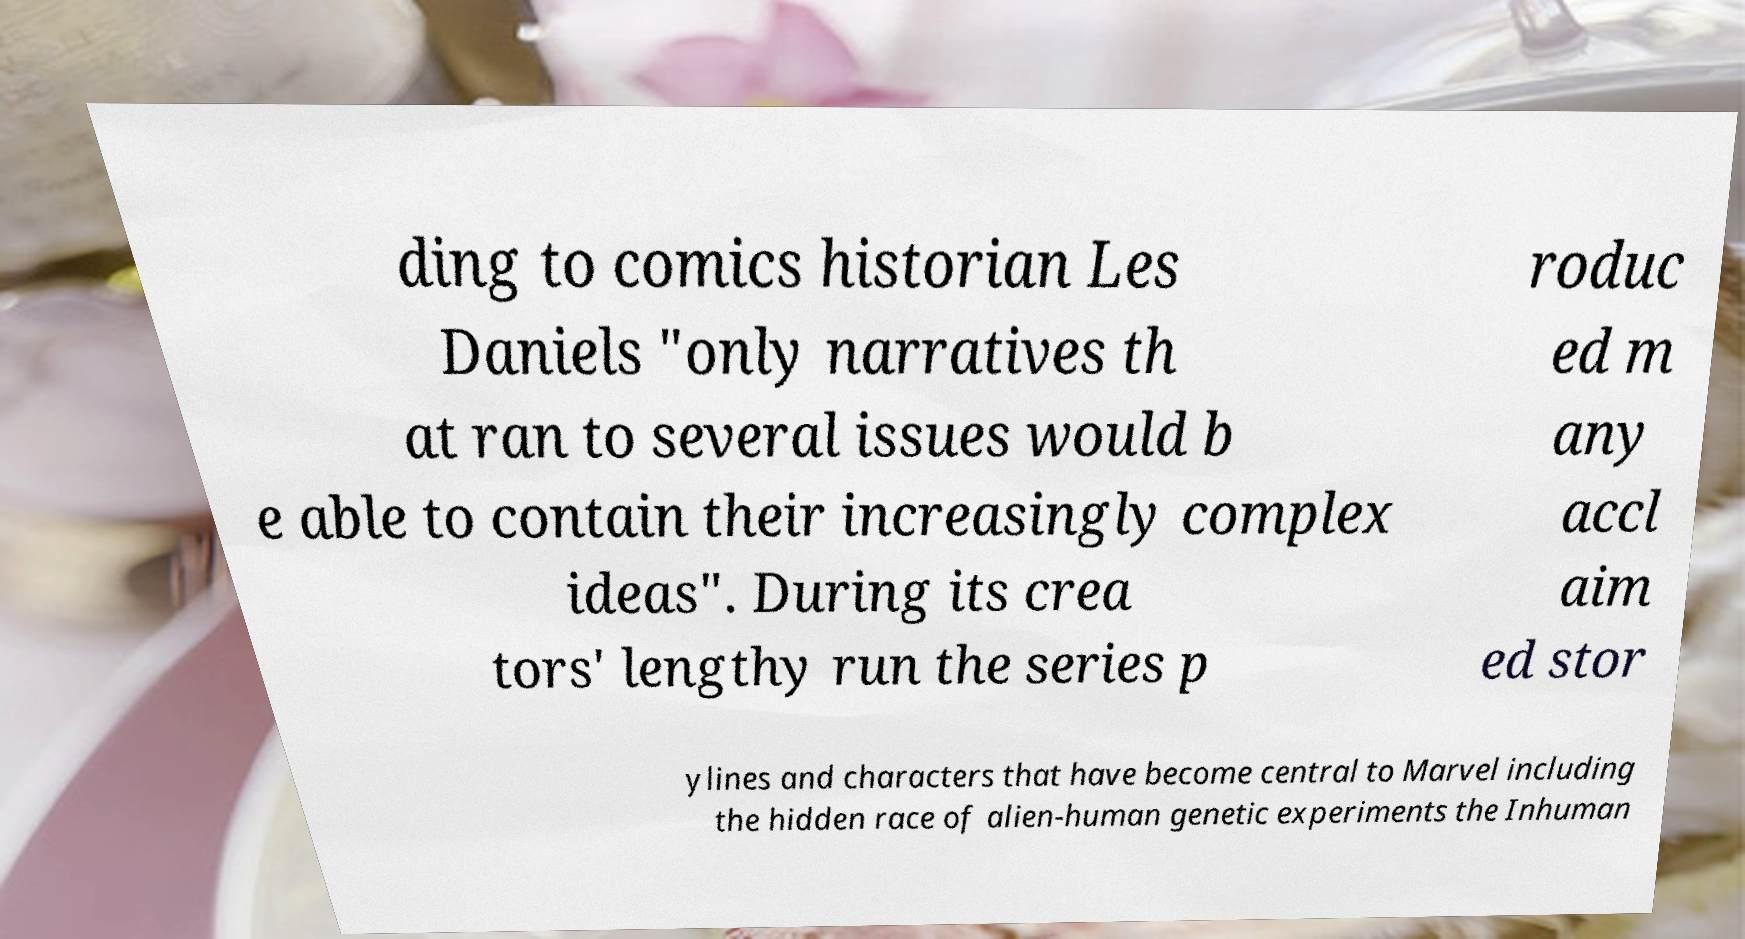Can you accurately transcribe the text from the provided image for me? ding to comics historian Les Daniels "only narratives th at ran to several issues would b e able to contain their increasingly complex ideas". During its crea tors' lengthy run the series p roduc ed m any accl aim ed stor ylines and characters that have become central to Marvel including the hidden race of alien-human genetic experiments the Inhuman 